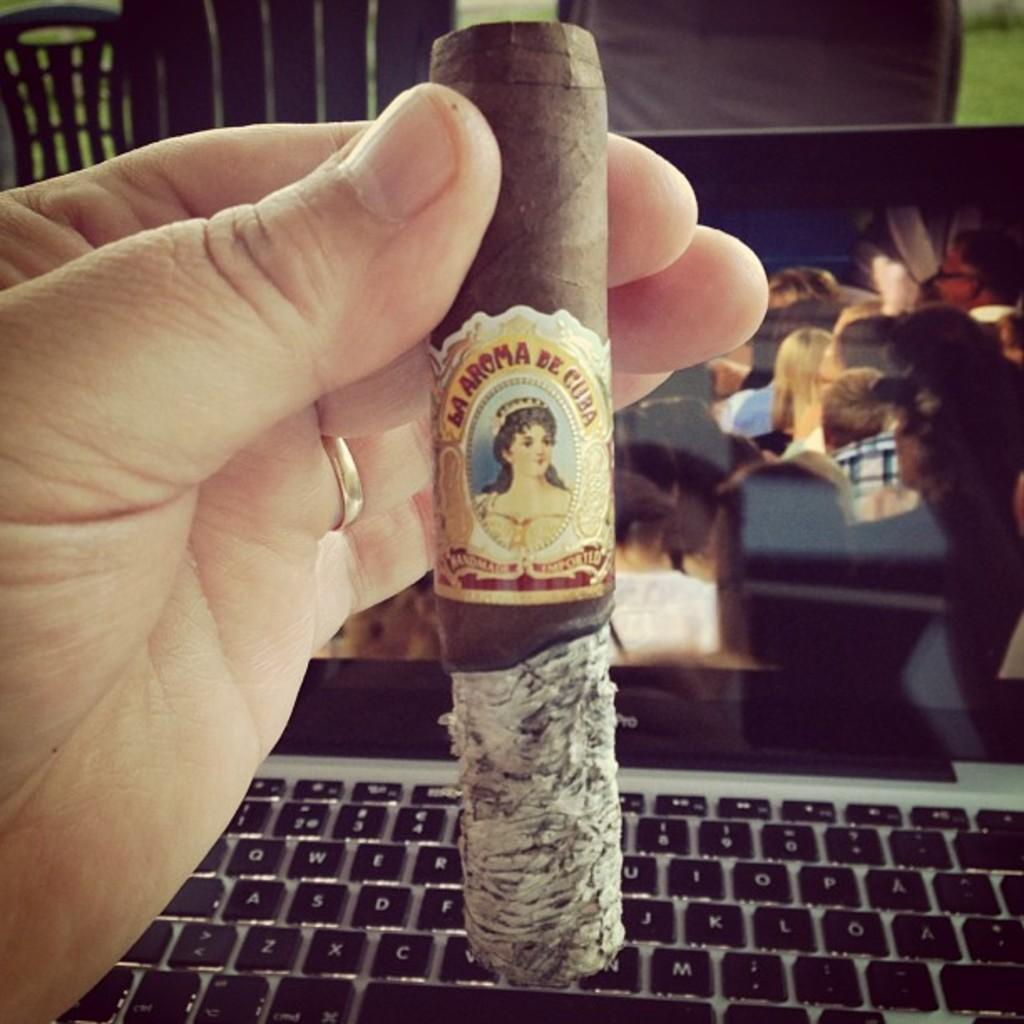<image>
Provide a brief description of the given image. A hand holds a Cuban cigar with a long section of ash still attached. 